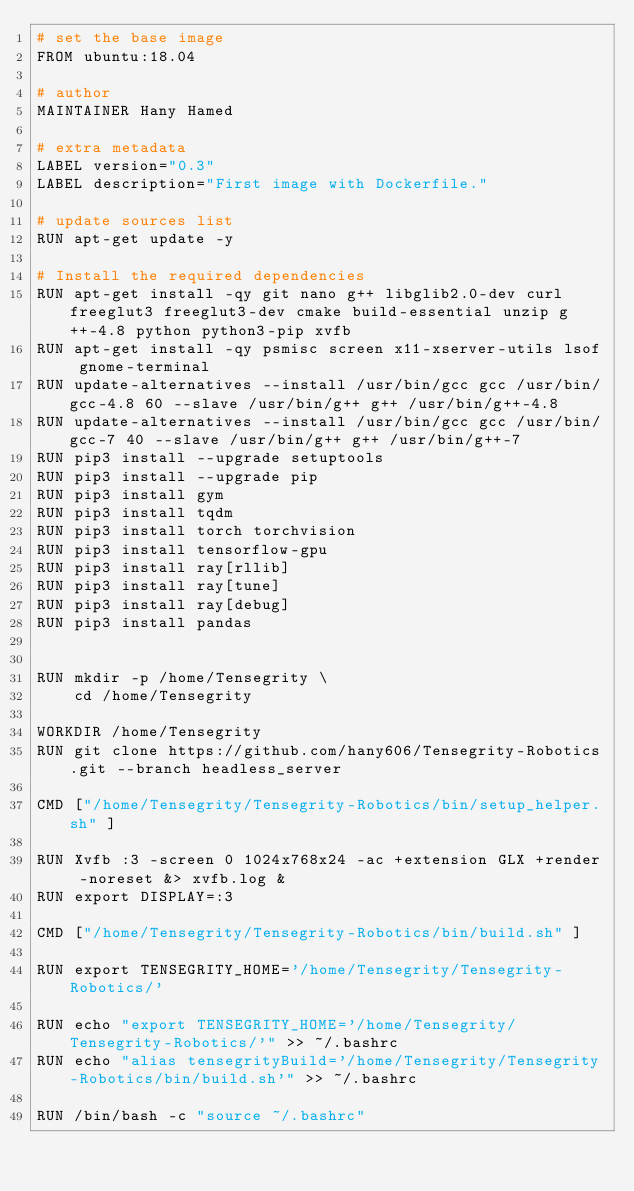Convert code to text. <code><loc_0><loc_0><loc_500><loc_500><_Dockerfile_># set the base image
FROM ubuntu:18.04

# author
MAINTAINER Hany Hamed

# extra metadata
LABEL version="0.3"
LABEL description="First image with Dockerfile."

# update sources list
RUN apt-get update -y

# Install the required dependencies
RUN apt-get install -qy git nano g++ libglib2.0-dev curl freeglut3 freeglut3-dev cmake build-essential unzip g++-4.8 python python3-pip xvfb
RUN apt-get install -qy psmisc screen x11-xserver-utils lsof gnome-terminal
RUN update-alternatives --install /usr/bin/gcc gcc /usr/bin/gcc-4.8 60 --slave /usr/bin/g++ g++ /usr/bin/g++-4.8
RUN update-alternatives --install /usr/bin/gcc gcc /usr/bin/gcc-7 40 --slave /usr/bin/g++ g++ /usr/bin/g++-7
RUN pip3 install --upgrade setuptools
RUN pip3 install --upgrade pip
RUN pip3 install gym
RUN pip3 install tqdm
RUN pip3 install torch torchvision
RUN pip3 install tensorflow-gpu
RUN pip3 install ray[rllib]
RUN pip3 install ray[tune]
RUN pip3 install ray[debug]
RUN pip3 install pandas


RUN mkdir -p /home/Tensegrity \
    cd /home/Tensegrity

WORKDIR /home/Tensegrity
RUN git clone https://github.com/hany606/Tensegrity-Robotics.git --branch headless_server

CMD ["/home/Tensegrity/Tensegrity-Robotics/bin/setup_helper.sh" ]

RUN Xvfb :3 -screen 0 1024x768x24 -ac +extension GLX +render -noreset &> xvfb.log &
RUN export DISPLAY=:3

CMD ["/home/Tensegrity/Tensegrity-Robotics/bin/build.sh" ]

RUN export TENSEGRITY_HOME='/home/Tensegrity/Tensegrity-Robotics/'

RUN echo "export TENSEGRITY_HOME='/home/Tensegrity/Tensegrity-Robotics/'" >> ~/.bashrc
RUN echo "alias tensegrityBuild='/home/Tensegrity/Tensegrity-Robotics/bin/build.sh'" >> ~/.bashrc

RUN /bin/bash -c "source ~/.bashrc"




</code> 